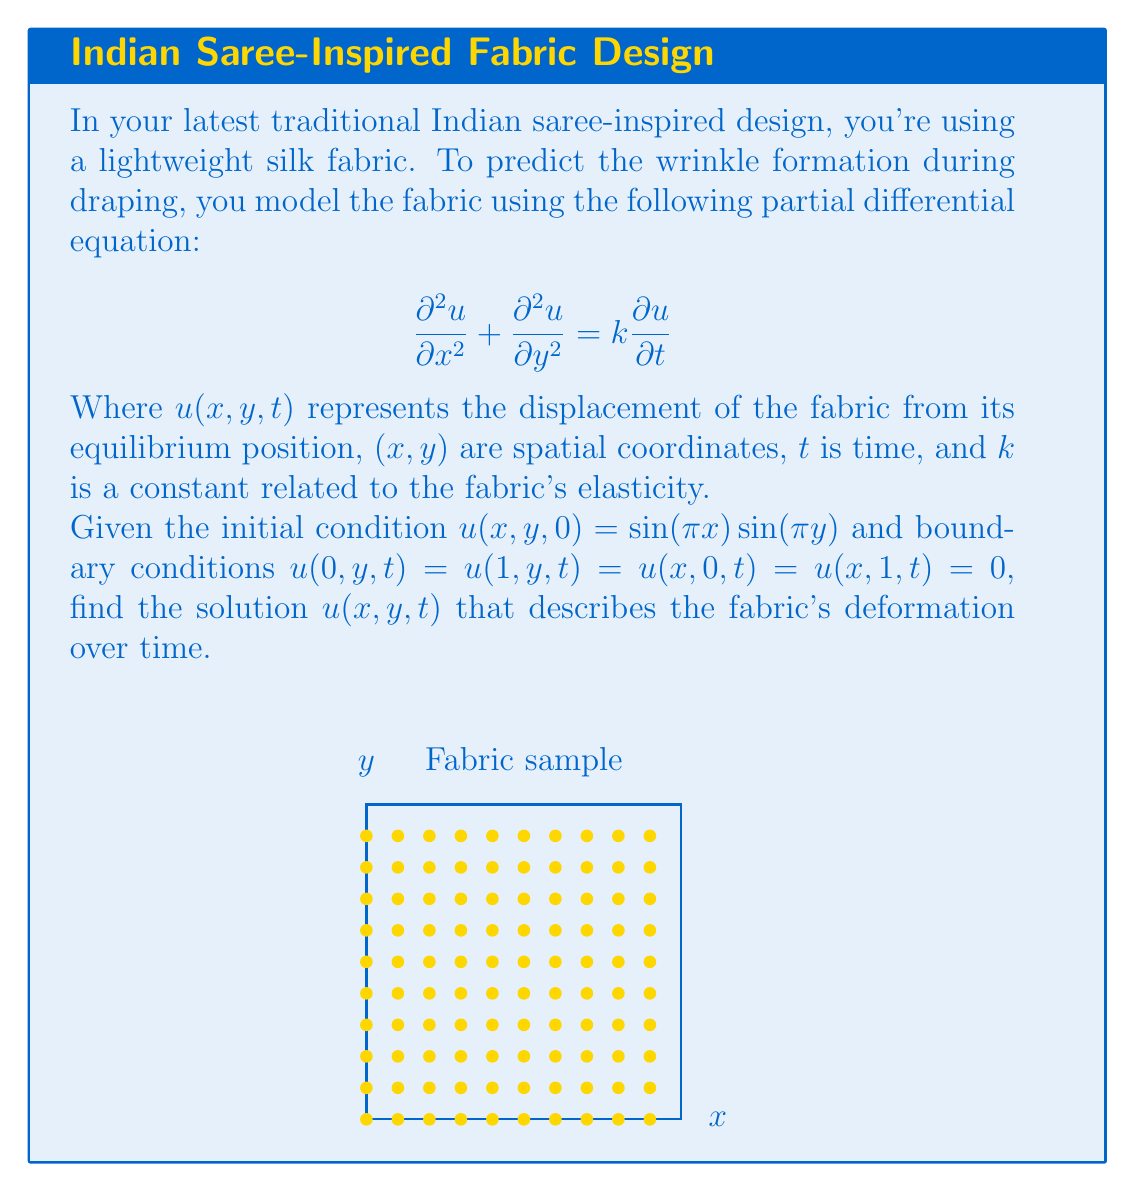Provide a solution to this math problem. To solve this partial differential equation (PDE), we'll use the method of separation of variables.

Step 1: Assume the solution has the form $u(x,y,t) = X(x)Y(y)T(t)$.

Step 2: Substitute this into the PDE:
$$X''YT + XY''T = kXYT'$$

Step 3: Divide by XYT:
$$\frac{X''}{X} + \frac{Y''}{Y} = k\frac{T'}{T} = -\lambda$$

Where $\lambda$ is a separation constant.

Step 4: This gives us three ordinary differential equations:
1) $X'' + \lambda_1 X = 0$
2) $Y'' + \lambda_2 Y = 0$
3) $T' + \frac{\lambda}{k}T = 0$, where $\lambda = \lambda_1 + \lambda_2$

Step 5: Solve these equations considering the boundary conditions:
1) $X(x) = \sin(n\pi x)$, $\lambda_1 = n^2\pi^2$
2) $Y(y) = \sin(m\pi y)$, $\lambda_2 = m^2\pi^2$
3) $T(t) = e^{-(\lambda_1 + \lambda_2)kt/2} = e^{-(n^2+m^2)\pi^2kt/2}$

Step 6: The general solution is:
$$u(x,y,t) = \sum_{n=1}^{\infty}\sum_{m=1}^{\infty}A_{nm}\sin(n\pi x)\sin(m\pi y)e^{-(n^2+m^2)\pi^2kt/2}$$

Step 7: Apply the initial condition to find $A_{nm}$:
$$u(x,y,0) = \sin(\pi x)\sin(\pi y) = \sum_{n=1}^{\infty}\sum_{m=1}^{\infty}A_{nm}\sin(n\pi x)\sin(m\pi y)$$

This implies $A_{11} = 1$ and all other $A_{nm} = 0$.

Therefore, the final solution is:
$$u(x,y,t) = \sin(\pi x)\sin(\pi y)e^{-2\pi^2kt/2}$$
Answer: $u(x,y,t) = \sin(\pi x)\sin(\pi y)e^{-\pi^2kt}$ 